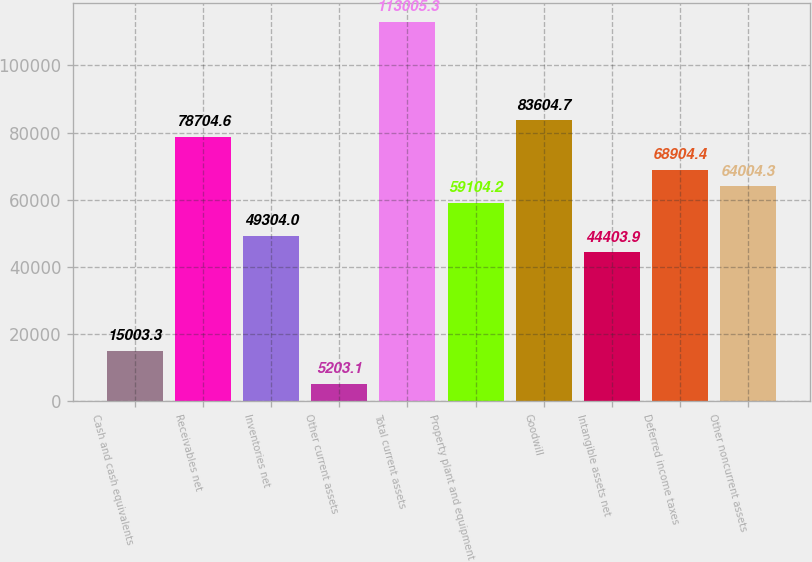Convert chart to OTSL. <chart><loc_0><loc_0><loc_500><loc_500><bar_chart><fcel>Cash and cash equivalents<fcel>Receivables net<fcel>Inventories net<fcel>Other current assets<fcel>Total current assets<fcel>Property plant and equipment<fcel>Goodwill<fcel>Intangible assets net<fcel>Deferred income taxes<fcel>Other noncurrent assets<nl><fcel>15003.3<fcel>78704.6<fcel>49304<fcel>5203.1<fcel>113005<fcel>59104.2<fcel>83604.7<fcel>44403.9<fcel>68904.4<fcel>64004.3<nl></chart> 